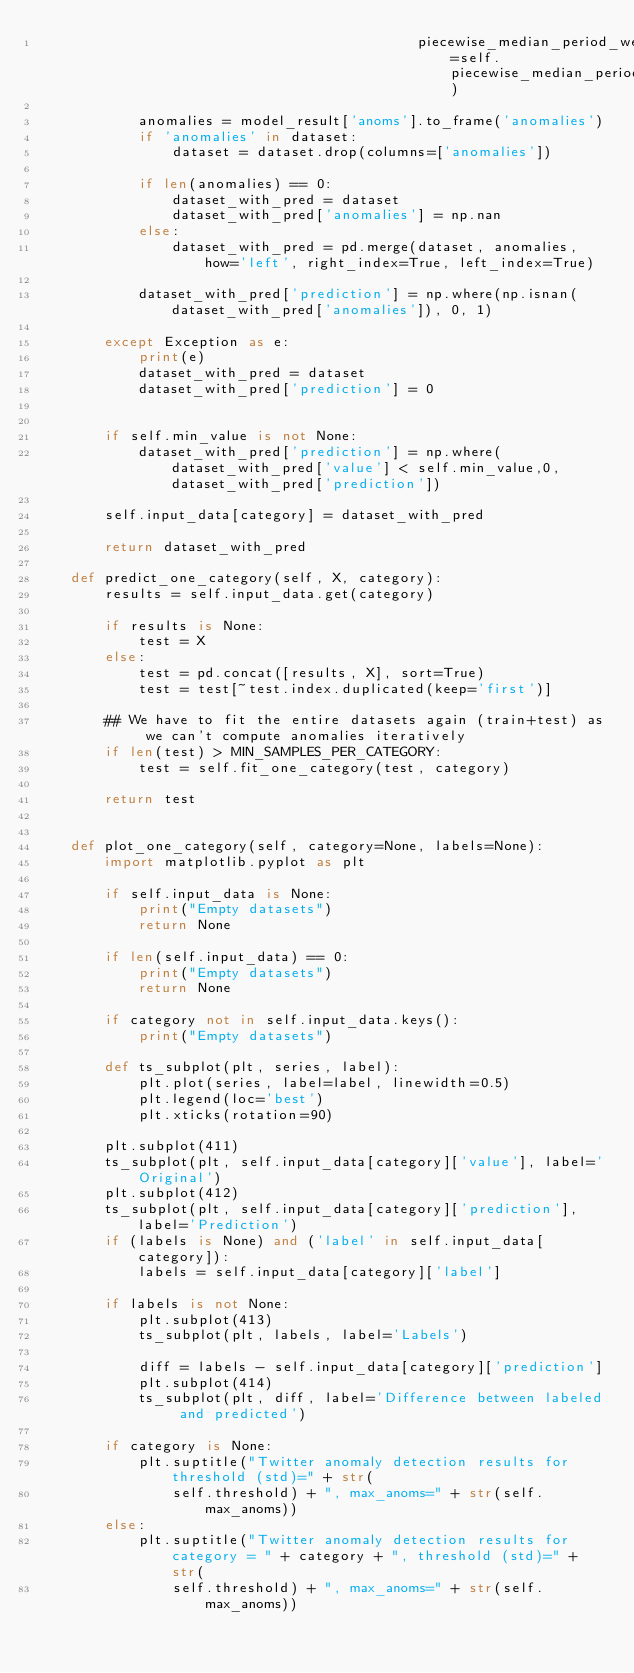<code> <loc_0><loc_0><loc_500><loc_500><_Python_>                                             piecewise_median_period_weeks=self.piecewise_median_period_weeks)

            anomalies = model_result['anoms'].to_frame('anomalies')
            if 'anomalies' in dataset:
                dataset = dataset.drop(columns=['anomalies'])

            if len(anomalies) == 0:
                dataset_with_pred = dataset
                dataset_with_pred['anomalies'] = np.nan
            else:
                dataset_with_pred = pd.merge(dataset, anomalies, how='left', right_index=True, left_index=True)

            dataset_with_pred['prediction'] = np.where(np.isnan(dataset_with_pred['anomalies']), 0, 1)

        except Exception as e:
            print(e)
            dataset_with_pred = dataset
            dataset_with_pred['prediction'] = 0


        if self.min_value is not None:
            dataset_with_pred['prediction'] = np.where(dataset_with_pred['value'] < self.min_value,0,dataset_with_pred['prediction'])

        self.input_data[category] = dataset_with_pred

        return dataset_with_pred

    def predict_one_category(self, X, category):
        results = self.input_data.get(category)

        if results is None:
            test = X
        else:
            test = pd.concat([results, X], sort=True)
            test = test[~test.index.duplicated(keep='first')]

        ## We have to fit the entire datasets again (train+test) as we can't compute anomalies iteratively
        if len(test) > MIN_SAMPLES_PER_CATEGORY:
            test = self.fit_one_category(test, category)

        return test


    def plot_one_category(self, category=None, labels=None):
        import matplotlib.pyplot as plt

        if self.input_data is None:
            print("Empty datasets")
            return None

        if len(self.input_data) == 0:
            print("Empty datasets")
            return None

        if category not in self.input_data.keys():
            print("Empty datasets")

        def ts_subplot(plt, series, label):
            plt.plot(series, label=label, linewidth=0.5)
            plt.legend(loc='best')
            plt.xticks(rotation=90)

        plt.subplot(411)
        ts_subplot(plt, self.input_data[category]['value'], label='Original')
        plt.subplot(412)
        ts_subplot(plt, self.input_data[category]['prediction'], label='Prediction')
        if (labels is None) and ('label' in self.input_data[category]):
            labels = self.input_data[category]['label']

        if labels is not None:
            plt.subplot(413)
            ts_subplot(plt, labels, label='Labels')

            diff = labels - self.input_data[category]['prediction']
            plt.subplot(414)
            ts_subplot(plt, diff, label='Difference between labeled and predicted')

        if category is None:
            plt.suptitle("Twitter anomaly detection results for threshold (std)=" + str(
                self.threshold) + ", max_anoms=" + str(self.max_anoms))
        else:
            plt.suptitle("Twitter anomaly detection results for category = " + category + ", threshold (std)=" + str(
                self.threshold) + ", max_anoms=" + str(self.max_anoms))
</code> 